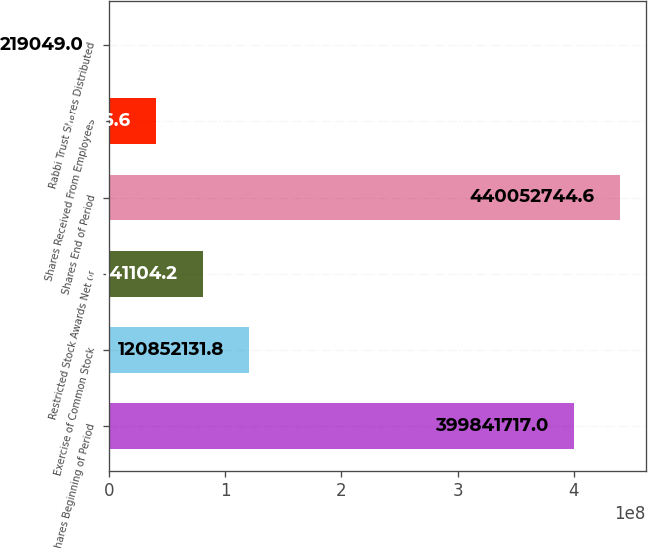Convert chart. <chart><loc_0><loc_0><loc_500><loc_500><bar_chart><fcel>Shares Beginning of Period<fcel>Exercise of Common Stock<fcel>Restricted Stock Awards Net of<fcel>Shares End of Period<fcel>Shares Received From Employees<fcel>Rabbi Trust Shares Distributed<nl><fcel>3.99842e+08<fcel>1.20852e+08<fcel>8.06411e+07<fcel>4.40053e+08<fcel>4.04301e+07<fcel>219049<nl></chart> 